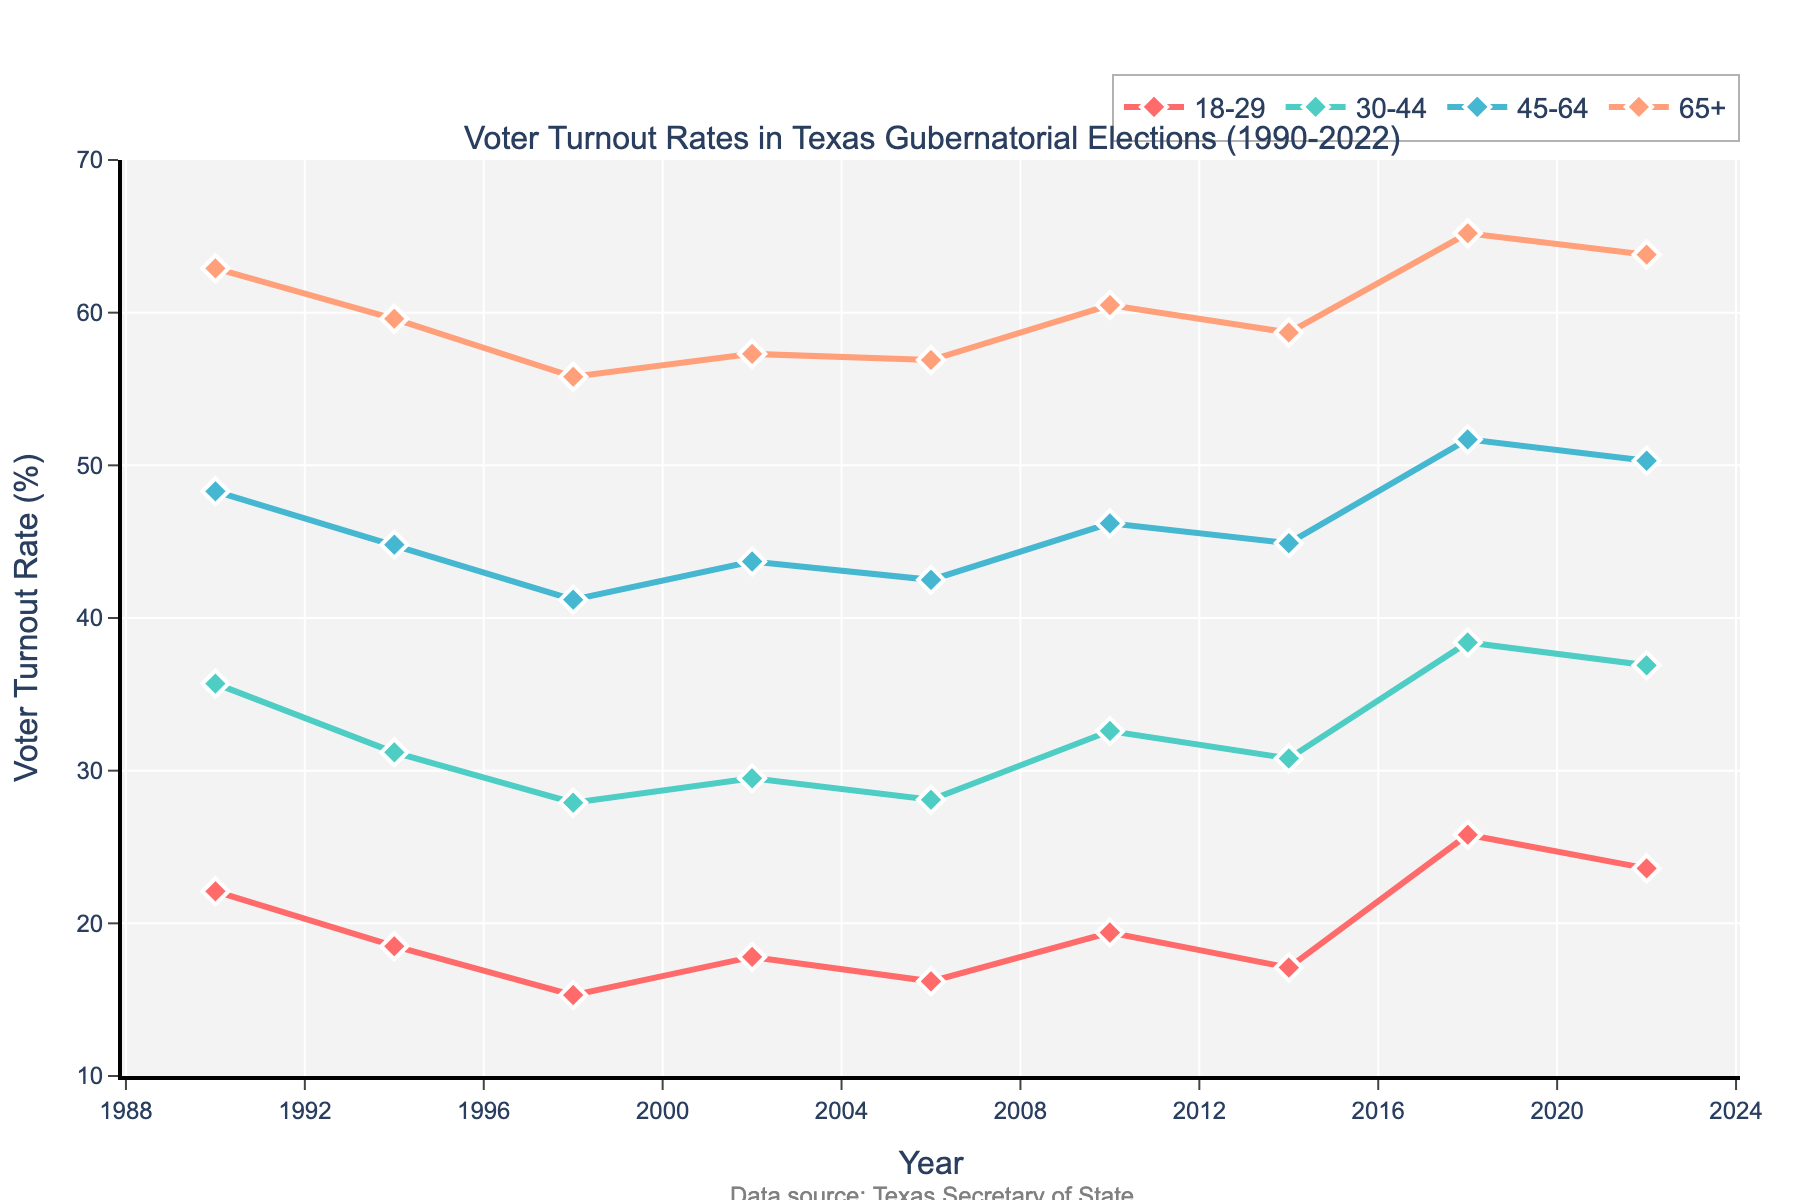What is the voter turnout rate for the 18-29 age group in 1998? The figure shows the voter turnout rates for different age groups across various years. Locate the year 1998 on the x-axis and find the corresponding value for the 18-29 age group. The rate is 15.3%.
Answer: 15.3% Which age group had the highest voter turnout rate in 2018? Find the data points for the year 2018 for all age groups on the figure. Compare the values: 18-29 (25.8%), 30-44 (38.4%), 45-64 (51.7%), 65+ (65.2%). The age group with the highest turnout is 65+.
Answer: 65+ How did the voter turnout rate for the 30-44 age group change from 1990 to 2022? Compare the turnout rates for the 30-44 age group in the years 1990 (35.7%) and 2022 (36.9%). Subtract the rate in 1990 from the rate in 2022: 36.9% - 35.7% = 1.2%.
Answer: Increased by 1.2% What is the difference in voter turnout rates between the 65+ and 18-29 age groups in 2022? Locate the rates for both age groups in 2022 on the figure: 65+ (63.8%) and 18-29 (23.6%). Subtract the rate for 18-29 from the rate for 65+: 63.8% - 23.6% = 40.2%.
Answer: 40.2% Which age group had the most variability in voter turnout rates between 1990 and 2022? Look at the range of values for each age group from 1990 to 2022. The 18-29 age group values range from about 15.3% to 25.8%, and the other groups have relatively smaller ranges. The 18-29 age group exhibited the highest variability.
Answer: 18-29 What is the average voter turnout rate of the 45-64 age group across all years shown? Add the turnout rates of the 45-64 age group across the years: 48.3 + 44.8 + 41.2 + 43.7 + 42.5 + 46.2 + 44.9 + 51.7 + 50.3 = 413.6. Divide by the number of data points (9): 413.6 / 9 ≈ 45.96%.
Answer: 45.96% Compare the voter turnout rates of the 65+ age group in 1994 and 2018. By how much did it change? The turnout rates for the 65+ age group are 59.6% in 1994 and 65.2% in 2018. Subtract the 1994 rate from the 2018 rate: 65.2% - 59.6% = 5.6%.
Answer: Increased by 5.6% Was the voter turnout rate for the 30-44 age group higher or lower than the overall average rate for this group in 2010? First, calculate the average voter turnout rate for the 30-44 age group from the data across all years: (35.7 + 31.2 + 27.9 + 29.5 + 28.1 + 32.6 + 30.8 + 38.4 + 36.9) / 9 ≈ 32.34%. The 2010 rate is 32.6%, which is higher than the average.
Answer: Higher Between which years did the 18-29 age group see the largest increase in voter turnout? Look for the largest difference between adjacent years in the 18-29 age group. The largest increase occurred between 2014 (17.1%) and 2018 (25.8%): 25.8% - 17.1% = 8.7%.
Answer: 2014-2018 